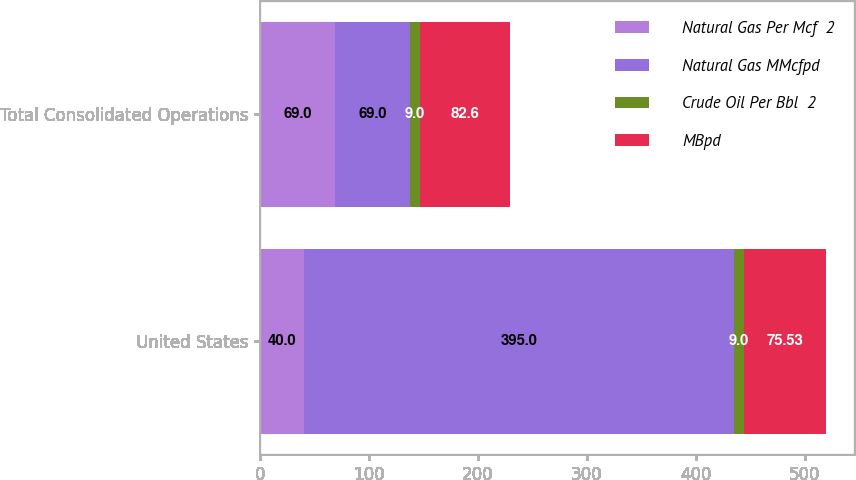Convert chart. <chart><loc_0><loc_0><loc_500><loc_500><stacked_bar_chart><ecel><fcel>United States<fcel>Total Consolidated Operations<nl><fcel>Natural Gas Per Mcf  2<fcel>40<fcel>69<nl><fcel>Natural Gas MMcfpd<fcel>395<fcel>69<nl><fcel>Crude Oil Per Bbl  2<fcel>9<fcel>9<nl><fcel>MBpd<fcel>75.53<fcel>82.6<nl></chart> 